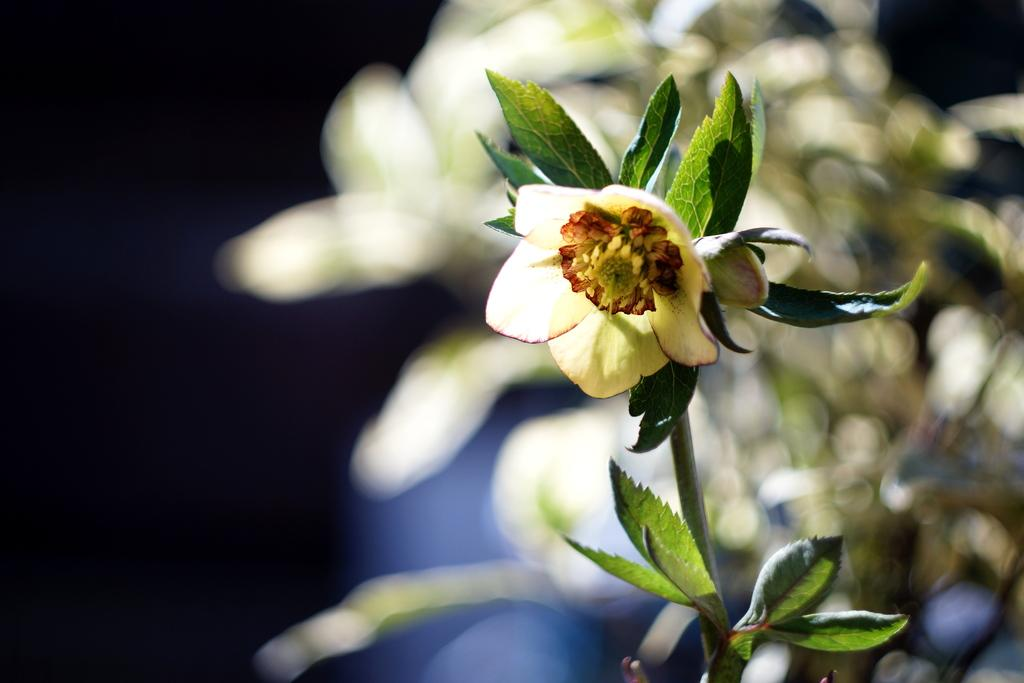What is the main subject of the image? There is a flower in the image. What else can be seen in the image besides the flower? There are leaves in the image. Can you describe the plant on the right side of the image? It appears to be a plant on the right side of the image. How would you describe the background of the image? The background of the image is blurry. What type of queen is sitting on the boundary in the image? There is no queen or boundary present in the image; it features a flower and leaves. 